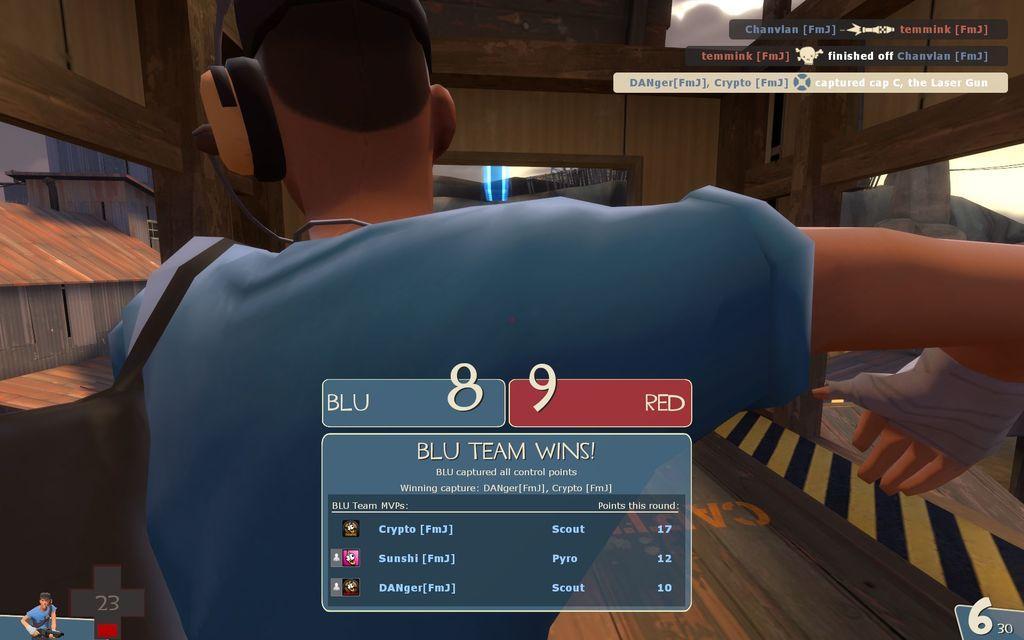Can you describe this image briefly? In this image we can see an animated person. We can see the animated text and few logos in the image. There are few buildings in the image. 